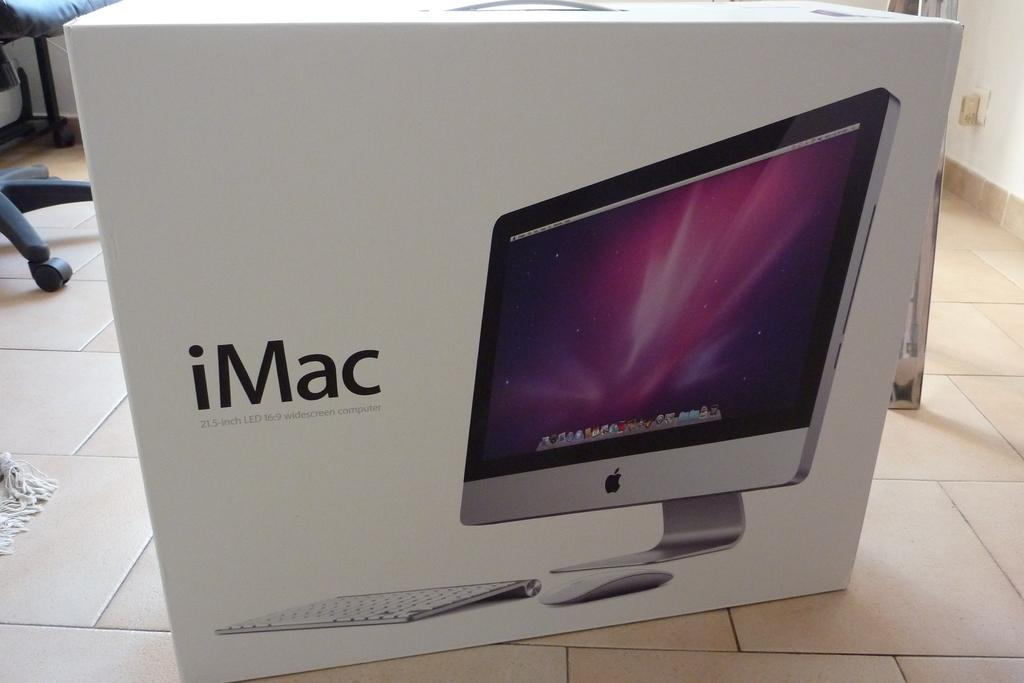<image>
Write a terse but informative summary of the picture. A white box says iMac and shows an Apple computer. 